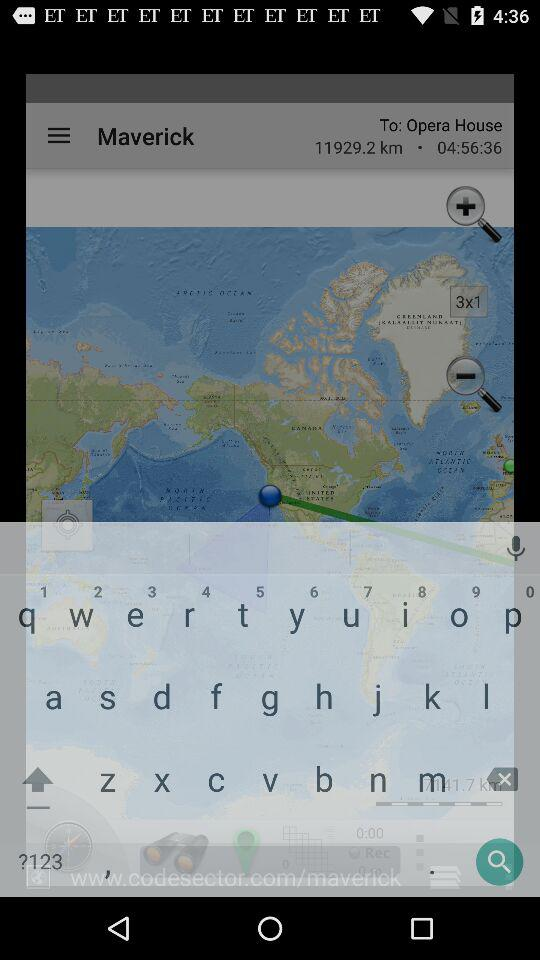What is the current location? The current location is "Maverick". 